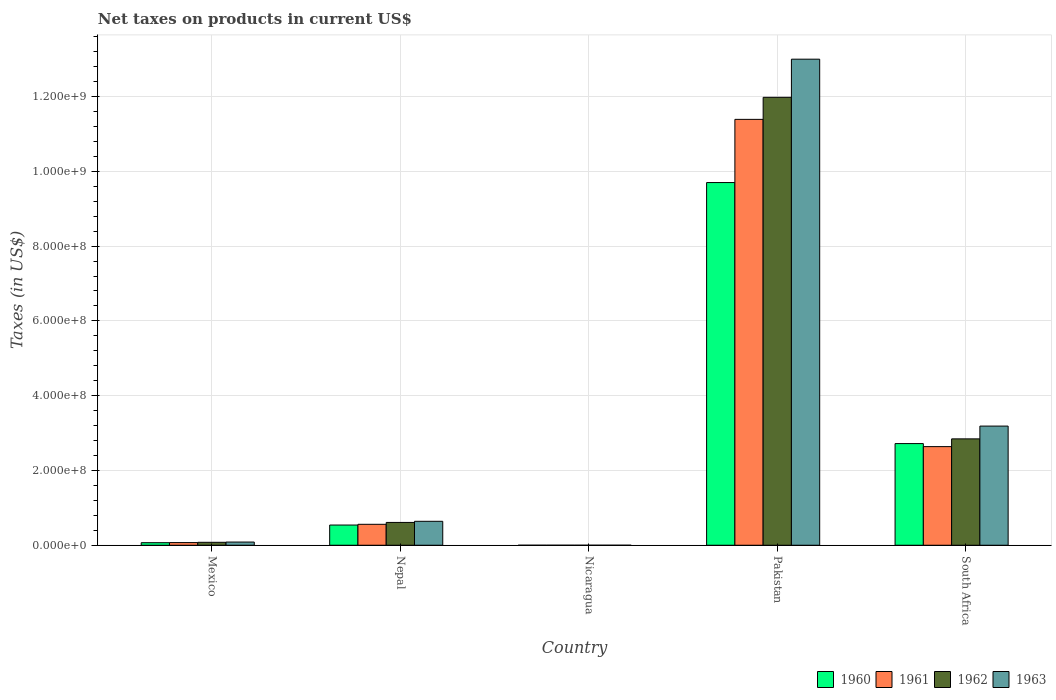How many different coloured bars are there?
Offer a terse response. 4. How many bars are there on the 4th tick from the left?
Provide a short and direct response. 4. What is the label of the 2nd group of bars from the left?
Offer a terse response. Nepal. In how many cases, is the number of bars for a given country not equal to the number of legend labels?
Keep it short and to the point. 0. What is the net taxes on products in 1960 in Mexico?
Give a very brief answer. 6.81e+06. Across all countries, what is the maximum net taxes on products in 1963?
Make the answer very short. 1.30e+09. Across all countries, what is the minimum net taxes on products in 1962?
Ensure brevity in your answer.  0.04. In which country was the net taxes on products in 1963 maximum?
Offer a very short reply. Pakistan. In which country was the net taxes on products in 1962 minimum?
Your answer should be compact. Nicaragua. What is the total net taxes on products in 1963 in the graph?
Provide a succinct answer. 1.69e+09. What is the difference between the net taxes on products in 1963 in Nicaragua and that in South Africa?
Keep it short and to the point. -3.19e+08. What is the difference between the net taxes on products in 1963 in Nepal and the net taxes on products in 1962 in Nicaragua?
Offer a terse response. 6.40e+07. What is the average net taxes on products in 1961 per country?
Offer a very short reply. 2.93e+08. What is the difference between the net taxes on products of/in 1961 and net taxes on products of/in 1963 in Mexico?
Keep it short and to the point. -1.41e+06. In how many countries, is the net taxes on products in 1963 greater than 1040000000 US$?
Offer a terse response. 1. What is the ratio of the net taxes on products in 1962 in Pakistan to that in South Africa?
Keep it short and to the point. 4.21. Is the difference between the net taxes on products in 1961 in Mexico and Nicaragua greater than the difference between the net taxes on products in 1963 in Mexico and Nicaragua?
Offer a very short reply. No. What is the difference between the highest and the second highest net taxes on products in 1962?
Make the answer very short. 9.14e+08. What is the difference between the highest and the lowest net taxes on products in 1960?
Keep it short and to the point. 9.70e+08. In how many countries, is the net taxes on products in 1960 greater than the average net taxes on products in 1960 taken over all countries?
Give a very brief answer. 2. Is it the case that in every country, the sum of the net taxes on products in 1962 and net taxes on products in 1963 is greater than the sum of net taxes on products in 1961 and net taxes on products in 1960?
Offer a terse response. No. What does the 2nd bar from the left in Nicaragua represents?
Make the answer very short. 1961. Is it the case that in every country, the sum of the net taxes on products in 1962 and net taxes on products in 1960 is greater than the net taxes on products in 1961?
Keep it short and to the point. Yes. How many countries are there in the graph?
Give a very brief answer. 5. Does the graph contain any zero values?
Make the answer very short. No. Does the graph contain grids?
Offer a very short reply. Yes. Where does the legend appear in the graph?
Give a very brief answer. Bottom right. How many legend labels are there?
Your response must be concise. 4. How are the legend labels stacked?
Your response must be concise. Horizontal. What is the title of the graph?
Your response must be concise. Net taxes on products in current US$. Does "1997" appear as one of the legend labels in the graph?
Your answer should be compact. No. What is the label or title of the Y-axis?
Provide a short and direct response. Taxes (in US$). What is the Taxes (in US$) of 1960 in Mexico?
Offer a terse response. 6.81e+06. What is the Taxes (in US$) of 1961 in Mexico?
Your answer should be compact. 7.08e+06. What is the Taxes (in US$) of 1962 in Mexico?
Your response must be concise. 7.85e+06. What is the Taxes (in US$) of 1963 in Mexico?
Your answer should be very brief. 8.49e+06. What is the Taxes (in US$) in 1960 in Nepal?
Your answer should be compact. 5.40e+07. What is the Taxes (in US$) of 1961 in Nepal?
Ensure brevity in your answer.  5.60e+07. What is the Taxes (in US$) in 1962 in Nepal?
Provide a succinct answer. 6.10e+07. What is the Taxes (in US$) in 1963 in Nepal?
Provide a succinct answer. 6.40e+07. What is the Taxes (in US$) in 1960 in Nicaragua?
Your answer should be compact. 0.03. What is the Taxes (in US$) of 1961 in Nicaragua?
Your response must be concise. 0.03. What is the Taxes (in US$) in 1962 in Nicaragua?
Keep it short and to the point. 0.04. What is the Taxes (in US$) in 1963 in Nicaragua?
Give a very brief answer. 0.04. What is the Taxes (in US$) of 1960 in Pakistan?
Provide a succinct answer. 9.70e+08. What is the Taxes (in US$) in 1961 in Pakistan?
Provide a succinct answer. 1.14e+09. What is the Taxes (in US$) of 1962 in Pakistan?
Your answer should be compact. 1.20e+09. What is the Taxes (in US$) of 1963 in Pakistan?
Make the answer very short. 1.30e+09. What is the Taxes (in US$) of 1960 in South Africa?
Provide a short and direct response. 2.72e+08. What is the Taxes (in US$) in 1961 in South Africa?
Provide a short and direct response. 2.64e+08. What is the Taxes (in US$) in 1962 in South Africa?
Your answer should be compact. 2.84e+08. What is the Taxes (in US$) in 1963 in South Africa?
Provide a succinct answer. 3.19e+08. Across all countries, what is the maximum Taxes (in US$) of 1960?
Ensure brevity in your answer.  9.70e+08. Across all countries, what is the maximum Taxes (in US$) of 1961?
Offer a terse response. 1.14e+09. Across all countries, what is the maximum Taxes (in US$) in 1962?
Offer a terse response. 1.20e+09. Across all countries, what is the maximum Taxes (in US$) of 1963?
Make the answer very short. 1.30e+09. Across all countries, what is the minimum Taxes (in US$) in 1960?
Offer a terse response. 0.03. Across all countries, what is the minimum Taxes (in US$) in 1961?
Offer a terse response. 0.03. Across all countries, what is the minimum Taxes (in US$) in 1962?
Your answer should be very brief. 0.04. Across all countries, what is the minimum Taxes (in US$) of 1963?
Offer a terse response. 0.04. What is the total Taxes (in US$) of 1960 in the graph?
Offer a terse response. 1.30e+09. What is the total Taxes (in US$) in 1961 in the graph?
Give a very brief answer. 1.47e+09. What is the total Taxes (in US$) of 1962 in the graph?
Offer a very short reply. 1.55e+09. What is the total Taxes (in US$) in 1963 in the graph?
Keep it short and to the point. 1.69e+09. What is the difference between the Taxes (in US$) in 1960 in Mexico and that in Nepal?
Your answer should be very brief. -4.72e+07. What is the difference between the Taxes (in US$) in 1961 in Mexico and that in Nepal?
Give a very brief answer. -4.89e+07. What is the difference between the Taxes (in US$) of 1962 in Mexico and that in Nepal?
Provide a succinct answer. -5.32e+07. What is the difference between the Taxes (in US$) of 1963 in Mexico and that in Nepal?
Make the answer very short. -5.55e+07. What is the difference between the Taxes (in US$) of 1960 in Mexico and that in Nicaragua?
Provide a succinct answer. 6.81e+06. What is the difference between the Taxes (in US$) of 1961 in Mexico and that in Nicaragua?
Give a very brief answer. 7.08e+06. What is the difference between the Taxes (in US$) in 1962 in Mexico and that in Nicaragua?
Keep it short and to the point. 7.85e+06. What is the difference between the Taxes (in US$) of 1963 in Mexico and that in Nicaragua?
Your answer should be compact. 8.49e+06. What is the difference between the Taxes (in US$) in 1960 in Mexico and that in Pakistan?
Provide a short and direct response. -9.63e+08. What is the difference between the Taxes (in US$) of 1961 in Mexico and that in Pakistan?
Your response must be concise. -1.13e+09. What is the difference between the Taxes (in US$) of 1962 in Mexico and that in Pakistan?
Your answer should be compact. -1.19e+09. What is the difference between the Taxes (in US$) in 1963 in Mexico and that in Pakistan?
Ensure brevity in your answer.  -1.29e+09. What is the difference between the Taxes (in US$) in 1960 in Mexico and that in South Africa?
Ensure brevity in your answer.  -2.65e+08. What is the difference between the Taxes (in US$) of 1961 in Mexico and that in South Africa?
Offer a very short reply. -2.57e+08. What is the difference between the Taxes (in US$) of 1962 in Mexico and that in South Africa?
Keep it short and to the point. -2.77e+08. What is the difference between the Taxes (in US$) of 1963 in Mexico and that in South Africa?
Offer a very short reply. -3.10e+08. What is the difference between the Taxes (in US$) of 1960 in Nepal and that in Nicaragua?
Your answer should be very brief. 5.40e+07. What is the difference between the Taxes (in US$) of 1961 in Nepal and that in Nicaragua?
Offer a very short reply. 5.60e+07. What is the difference between the Taxes (in US$) in 1962 in Nepal and that in Nicaragua?
Offer a terse response. 6.10e+07. What is the difference between the Taxes (in US$) of 1963 in Nepal and that in Nicaragua?
Make the answer very short. 6.40e+07. What is the difference between the Taxes (in US$) in 1960 in Nepal and that in Pakistan?
Keep it short and to the point. -9.16e+08. What is the difference between the Taxes (in US$) of 1961 in Nepal and that in Pakistan?
Provide a succinct answer. -1.08e+09. What is the difference between the Taxes (in US$) in 1962 in Nepal and that in Pakistan?
Provide a short and direct response. -1.14e+09. What is the difference between the Taxes (in US$) in 1963 in Nepal and that in Pakistan?
Offer a very short reply. -1.24e+09. What is the difference between the Taxes (in US$) of 1960 in Nepal and that in South Africa?
Ensure brevity in your answer.  -2.18e+08. What is the difference between the Taxes (in US$) in 1961 in Nepal and that in South Africa?
Your response must be concise. -2.08e+08. What is the difference between the Taxes (in US$) of 1962 in Nepal and that in South Africa?
Offer a terse response. -2.23e+08. What is the difference between the Taxes (in US$) in 1963 in Nepal and that in South Africa?
Keep it short and to the point. -2.55e+08. What is the difference between the Taxes (in US$) in 1960 in Nicaragua and that in Pakistan?
Give a very brief answer. -9.70e+08. What is the difference between the Taxes (in US$) of 1961 in Nicaragua and that in Pakistan?
Ensure brevity in your answer.  -1.14e+09. What is the difference between the Taxes (in US$) in 1962 in Nicaragua and that in Pakistan?
Ensure brevity in your answer.  -1.20e+09. What is the difference between the Taxes (in US$) in 1963 in Nicaragua and that in Pakistan?
Provide a short and direct response. -1.30e+09. What is the difference between the Taxes (in US$) of 1960 in Nicaragua and that in South Africa?
Make the answer very short. -2.72e+08. What is the difference between the Taxes (in US$) of 1961 in Nicaragua and that in South Africa?
Keep it short and to the point. -2.64e+08. What is the difference between the Taxes (in US$) of 1962 in Nicaragua and that in South Africa?
Your answer should be compact. -2.84e+08. What is the difference between the Taxes (in US$) in 1963 in Nicaragua and that in South Africa?
Provide a succinct answer. -3.19e+08. What is the difference between the Taxes (in US$) in 1960 in Pakistan and that in South Africa?
Offer a very short reply. 6.98e+08. What is the difference between the Taxes (in US$) in 1961 in Pakistan and that in South Africa?
Make the answer very short. 8.75e+08. What is the difference between the Taxes (in US$) in 1962 in Pakistan and that in South Africa?
Provide a succinct answer. 9.14e+08. What is the difference between the Taxes (in US$) of 1963 in Pakistan and that in South Africa?
Offer a terse response. 9.81e+08. What is the difference between the Taxes (in US$) in 1960 in Mexico and the Taxes (in US$) in 1961 in Nepal?
Provide a succinct answer. -4.92e+07. What is the difference between the Taxes (in US$) in 1960 in Mexico and the Taxes (in US$) in 1962 in Nepal?
Your answer should be very brief. -5.42e+07. What is the difference between the Taxes (in US$) of 1960 in Mexico and the Taxes (in US$) of 1963 in Nepal?
Your answer should be very brief. -5.72e+07. What is the difference between the Taxes (in US$) of 1961 in Mexico and the Taxes (in US$) of 1962 in Nepal?
Provide a short and direct response. -5.39e+07. What is the difference between the Taxes (in US$) in 1961 in Mexico and the Taxes (in US$) in 1963 in Nepal?
Your answer should be compact. -5.69e+07. What is the difference between the Taxes (in US$) in 1962 in Mexico and the Taxes (in US$) in 1963 in Nepal?
Provide a short and direct response. -5.62e+07. What is the difference between the Taxes (in US$) of 1960 in Mexico and the Taxes (in US$) of 1961 in Nicaragua?
Ensure brevity in your answer.  6.81e+06. What is the difference between the Taxes (in US$) in 1960 in Mexico and the Taxes (in US$) in 1962 in Nicaragua?
Provide a succinct answer. 6.81e+06. What is the difference between the Taxes (in US$) of 1960 in Mexico and the Taxes (in US$) of 1963 in Nicaragua?
Keep it short and to the point. 6.81e+06. What is the difference between the Taxes (in US$) of 1961 in Mexico and the Taxes (in US$) of 1962 in Nicaragua?
Your answer should be very brief. 7.08e+06. What is the difference between the Taxes (in US$) in 1961 in Mexico and the Taxes (in US$) in 1963 in Nicaragua?
Ensure brevity in your answer.  7.08e+06. What is the difference between the Taxes (in US$) in 1962 in Mexico and the Taxes (in US$) in 1963 in Nicaragua?
Your answer should be very brief. 7.85e+06. What is the difference between the Taxes (in US$) of 1960 in Mexico and the Taxes (in US$) of 1961 in Pakistan?
Offer a terse response. -1.13e+09. What is the difference between the Taxes (in US$) of 1960 in Mexico and the Taxes (in US$) of 1962 in Pakistan?
Ensure brevity in your answer.  -1.19e+09. What is the difference between the Taxes (in US$) in 1960 in Mexico and the Taxes (in US$) in 1963 in Pakistan?
Your answer should be compact. -1.29e+09. What is the difference between the Taxes (in US$) of 1961 in Mexico and the Taxes (in US$) of 1962 in Pakistan?
Offer a terse response. -1.19e+09. What is the difference between the Taxes (in US$) of 1961 in Mexico and the Taxes (in US$) of 1963 in Pakistan?
Your answer should be compact. -1.29e+09. What is the difference between the Taxes (in US$) of 1962 in Mexico and the Taxes (in US$) of 1963 in Pakistan?
Provide a short and direct response. -1.29e+09. What is the difference between the Taxes (in US$) of 1960 in Mexico and the Taxes (in US$) of 1961 in South Africa?
Provide a short and direct response. -2.57e+08. What is the difference between the Taxes (in US$) of 1960 in Mexico and the Taxes (in US$) of 1962 in South Africa?
Offer a very short reply. -2.78e+08. What is the difference between the Taxes (in US$) in 1960 in Mexico and the Taxes (in US$) in 1963 in South Africa?
Make the answer very short. -3.12e+08. What is the difference between the Taxes (in US$) in 1961 in Mexico and the Taxes (in US$) in 1962 in South Africa?
Ensure brevity in your answer.  -2.77e+08. What is the difference between the Taxes (in US$) in 1961 in Mexico and the Taxes (in US$) in 1963 in South Africa?
Your answer should be very brief. -3.12e+08. What is the difference between the Taxes (in US$) of 1962 in Mexico and the Taxes (in US$) of 1963 in South Africa?
Your response must be concise. -3.11e+08. What is the difference between the Taxes (in US$) of 1960 in Nepal and the Taxes (in US$) of 1961 in Nicaragua?
Give a very brief answer. 5.40e+07. What is the difference between the Taxes (in US$) of 1960 in Nepal and the Taxes (in US$) of 1962 in Nicaragua?
Provide a succinct answer. 5.40e+07. What is the difference between the Taxes (in US$) in 1960 in Nepal and the Taxes (in US$) in 1963 in Nicaragua?
Ensure brevity in your answer.  5.40e+07. What is the difference between the Taxes (in US$) of 1961 in Nepal and the Taxes (in US$) of 1962 in Nicaragua?
Keep it short and to the point. 5.60e+07. What is the difference between the Taxes (in US$) of 1961 in Nepal and the Taxes (in US$) of 1963 in Nicaragua?
Ensure brevity in your answer.  5.60e+07. What is the difference between the Taxes (in US$) of 1962 in Nepal and the Taxes (in US$) of 1963 in Nicaragua?
Provide a succinct answer. 6.10e+07. What is the difference between the Taxes (in US$) in 1960 in Nepal and the Taxes (in US$) in 1961 in Pakistan?
Your answer should be very brief. -1.08e+09. What is the difference between the Taxes (in US$) in 1960 in Nepal and the Taxes (in US$) in 1962 in Pakistan?
Your answer should be very brief. -1.14e+09. What is the difference between the Taxes (in US$) of 1960 in Nepal and the Taxes (in US$) of 1963 in Pakistan?
Your response must be concise. -1.25e+09. What is the difference between the Taxes (in US$) in 1961 in Nepal and the Taxes (in US$) in 1962 in Pakistan?
Make the answer very short. -1.14e+09. What is the difference between the Taxes (in US$) in 1961 in Nepal and the Taxes (in US$) in 1963 in Pakistan?
Offer a very short reply. -1.24e+09. What is the difference between the Taxes (in US$) in 1962 in Nepal and the Taxes (in US$) in 1963 in Pakistan?
Your answer should be compact. -1.24e+09. What is the difference between the Taxes (in US$) in 1960 in Nepal and the Taxes (in US$) in 1961 in South Africa?
Provide a short and direct response. -2.10e+08. What is the difference between the Taxes (in US$) in 1960 in Nepal and the Taxes (in US$) in 1962 in South Africa?
Your response must be concise. -2.30e+08. What is the difference between the Taxes (in US$) of 1960 in Nepal and the Taxes (in US$) of 1963 in South Africa?
Keep it short and to the point. -2.65e+08. What is the difference between the Taxes (in US$) of 1961 in Nepal and the Taxes (in US$) of 1962 in South Africa?
Provide a succinct answer. -2.28e+08. What is the difference between the Taxes (in US$) in 1961 in Nepal and the Taxes (in US$) in 1963 in South Africa?
Provide a succinct answer. -2.63e+08. What is the difference between the Taxes (in US$) in 1962 in Nepal and the Taxes (in US$) in 1963 in South Africa?
Offer a terse response. -2.58e+08. What is the difference between the Taxes (in US$) of 1960 in Nicaragua and the Taxes (in US$) of 1961 in Pakistan?
Offer a very short reply. -1.14e+09. What is the difference between the Taxes (in US$) of 1960 in Nicaragua and the Taxes (in US$) of 1962 in Pakistan?
Keep it short and to the point. -1.20e+09. What is the difference between the Taxes (in US$) in 1960 in Nicaragua and the Taxes (in US$) in 1963 in Pakistan?
Offer a very short reply. -1.30e+09. What is the difference between the Taxes (in US$) in 1961 in Nicaragua and the Taxes (in US$) in 1962 in Pakistan?
Keep it short and to the point. -1.20e+09. What is the difference between the Taxes (in US$) in 1961 in Nicaragua and the Taxes (in US$) in 1963 in Pakistan?
Provide a short and direct response. -1.30e+09. What is the difference between the Taxes (in US$) of 1962 in Nicaragua and the Taxes (in US$) of 1963 in Pakistan?
Your answer should be very brief. -1.30e+09. What is the difference between the Taxes (in US$) in 1960 in Nicaragua and the Taxes (in US$) in 1961 in South Africa?
Your response must be concise. -2.64e+08. What is the difference between the Taxes (in US$) in 1960 in Nicaragua and the Taxes (in US$) in 1962 in South Africa?
Your response must be concise. -2.84e+08. What is the difference between the Taxes (in US$) of 1960 in Nicaragua and the Taxes (in US$) of 1963 in South Africa?
Keep it short and to the point. -3.19e+08. What is the difference between the Taxes (in US$) in 1961 in Nicaragua and the Taxes (in US$) in 1962 in South Africa?
Offer a very short reply. -2.84e+08. What is the difference between the Taxes (in US$) in 1961 in Nicaragua and the Taxes (in US$) in 1963 in South Africa?
Make the answer very short. -3.19e+08. What is the difference between the Taxes (in US$) in 1962 in Nicaragua and the Taxes (in US$) in 1963 in South Africa?
Provide a succinct answer. -3.19e+08. What is the difference between the Taxes (in US$) of 1960 in Pakistan and the Taxes (in US$) of 1961 in South Africa?
Provide a short and direct response. 7.06e+08. What is the difference between the Taxes (in US$) of 1960 in Pakistan and the Taxes (in US$) of 1962 in South Africa?
Keep it short and to the point. 6.86e+08. What is the difference between the Taxes (in US$) in 1960 in Pakistan and the Taxes (in US$) in 1963 in South Africa?
Your response must be concise. 6.51e+08. What is the difference between the Taxes (in US$) of 1961 in Pakistan and the Taxes (in US$) of 1962 in South Africa?
Provide a succinct answer. 8.55e+08. What is the difference between the Taxes (in US$) of 1961 in Pakistan and the Taxes (in US$) of 1963 in South Africa?
Provide a succinct answer. 8.20e+08. What is the difference between the Taxes (in US$) in 1962 in Pakistan and the Taxes (in US$) in 1963 in South Africa?
Give a very brief answer. 8.79e+08. What is the average Taxes (in US$) of 1960 per country?
Give a very brief answer. 2.61e+08. What is the average Taxes (in US$) in 1961 per country?
Provide a short and direct response. 2.93e+08. What is the average Taxes (in US$) of 1962 per country?
Provide a succinct answer. 3.10e+08. What is the average Taxes (in US$) of 1963 per country?
Offer a terse response. 3.38e+08. What is the difference between the Taxes (in US$) of 1960 and Taxes (in US$) of 1961 in Mexico?
Make the answer very short. -2.73e+05. What is the difference between the Taxes (in US$) in 1960 and Taxes (in US$) in 1962 in Mexico?
Your response must be concise. -1.04e+06. What is the difference between the Taxes (in US$) in 1960 and Taxes (in US$) in 1963 in Mexico?
Your answer should be very brief. -1.69e+06. What is the difference between the Taxes (in US$) in 1961 and Taxes (in US$) in 1962 in Mexico?
Keep it short and to the point. -7.69e+05. What is the difference between the Taxes (in US$) in 1961 and Taxes (in US$) in 1963 in Mexico?
Offer a terse response. -1.41e+06. What is the difference between the Taxes (in US$) of 1962 and Taxes (in US$) of 1963 in Mexico?
Provide a succinct answer. -6.43e+05. What is the difference between the Taxes (in US$) in 1960 and Taxes (in US$) in 1962 in Nepal?
Offer a terse response. -7.00e+06. What is the difference between the Taxes (in US$) in 1960 and Taxes (in US$) in 1963 in Nepal?
Provide a succinct answer. -1.00e+07. What is the difference between the Taxes (in US$) in 1961 and Taxes (in US$) in 1962 in Nepal?
Provide a short and direct response. -5.00e+06. What is the difference between the Taxes (in US$) in 1961 and Taxes (in US$) in 1963 in Nepal?
Make the answer very short. -8.00e+06. What is the difference between the Taxes (in US$) in 1960 and Taxes (in US$) in 1961 in Nicaragua?
Make the answer very short. -0. What is the difference between the Taxes (in US$) of 1960 and Taxes (in US$) of 1962 in Nicaragua?
Make the answer very short. -0.01. What is the difference between the Taxes (in US$) of 1960 and Taxes (in US$) of 1963 in Nicaragua?
Your answer should be very brief. -0.01. What is the difference between the Taxes (in US$) in 1961 and Taxes (in US$) in 1962 in Nicaragua?
Offer a very short reply. -0. What is the difference between the Taxes (in US$) of 1961 and Taxes (in US$) of 1963 in Nicaragua?
Provide a short and direct response. -0.01. What is the difference between the Taxes (in US$) in 1962 and Taxes (in US$) in 1963 in Nicaragua?
Provide a short and direct response. -0.01. What is the difference between the Taxes (in US$) in 1960 and Taxes (in US$) in 1961 in Pakistan?
Your answer should be very brief. -1.69e+08. What is the difference between the Taxes (in US$) in 1960 and Taxes (in US$) in 1962 in Pakistan?
Provide a succinct answer. -2.28e+08. What is the difference between the Taxes (in US$) of 1960 and Taxes (in US$) of 1963 in Pakistan?
Keep it short and to the point. -3.30e+08. What is the difference between the Taxes (in US$) in 1961 and Taxes (in US$) in 1962 in Pakistan?
Your answer should be compact. -5.90e+07. What is the difference between the Taxes (in US$) in 1961 and Taxes (in US$) in 1963 in Pakistan?
Provide a short and direct response. -1.61e+08. What is the difference between the Taxes (in US$) of 1962 and Taxes (in US$) of 1963 in Pakistan?
Offer a very short reply. -1.02e+08. What is the difference between the Taxes (in US$) in 1960 and Taxes (in US$) in 1961 in South Africa?
Offer a very short reply. 8.10e+06. What is the difference between the Taxes (in US$) in 1960 and Taxes (in US$) in 1962 in South Africa?
Your answer should be compact. -1.26e+07. What is the difference between the Taxes (in US$) of 1960 and Taxes (in US$) of 1963 in South Africa?
Offer a very short reply. -4.68e+07. What is the difference between the Taxes (in US$) of 1961 and Taxes (in US$) of 1962 in South Africa?
Offer a very short reply. -2.07e+07. What is the difference between the Taxes (in US$) of 1961 and Taxes (in US$) of 1963 in South Africa?
Provide a succinct answer. -5.49e+07. What is the difference between the Taxes (in US$) in 1962 and Taxes (in US$) in 1963 in South Africa?
Your response must be concise. -3.42e+07. What is the ratio of the Taxes (in US$) in 1960 in Mexico to that in Nepal?
Keep it short and to the point. 0.13. What is the ratio of the Taxes (in US$) in 1961 in Mexico to that in Nepal?
Your answer should be very brief. 0.13. What is the ratio of the Taxes (in US$) of 1962 in Mexico to that in Nepal?
Provide a short and direct response. 0.13. What is the ratio of the Taxes (in US$) of 1963 in Mexico to that in Nepal?
Offer a terse response. 0.13. What is the ratio of the Taxes (in US$) of 1960 in Mexico to that in Nicaragua?
Ensure brevity in your answer.  2.29e+08. What is the ratio of the Taxes (in US$) in 1961 in Mexico to that in Nicaragua?
Your answer should be compact. 2.27e+08. What is the ratio of the Taxes (in US$) of 1962 in Mexico to that in Nicaragua?
Make the answer very short. 2.22e+08. What is the ratio of the Taxes (in US$) in 1963 in Mexico to that in Nicaragua?
Make the answer very short. 2.04e+08. What is the ratio of the Taxes (in US$) in 1960 in Mexico to that in Pakistan?
Give a very brief answer. 0.01. What is the ratio of the Taxes (in US$) of 1961 in Mexico to that in Pakistan?
Provide a succinct answer. 0.01. What is the ratio of the Taxes (in US$) in 1962 in Mexico to that in Pakistan?
Provide a succinct answer. 0.01. What is the ratio of the Taxes (in US$) of 1963 in Mexico to that in Pakistan?
Ensure brevity in your answer.  0.01. What is the ratio of the Taxes (in US$) of 1960 in Mexico to that in South Africa?
Your response must be concise. 0.03. What is the ratio of the Taxes (in US$) in 1961 in Mexico to that in South Africa?
Make the answer very short. 0.03. What is the ratio of the Taxes (in US$) in 1962 in Mexico to that in South Africa?
Your response must be concise. 0.03. What is the ratio of the Taxes (in US$) of 1963 in Mexico to that in South Africa?
Your answer should be compact. 0.03. What is the ratio of the Taxes (in US$) of 1960 in Nepal to that in Nicaragua?
Ensure brevity in your answer.  1.81e+09. What is the ratio of the Taxes (in US$) in 1961 in Nepal to that in Nicaragua?
Provide a succinct answer. 1.80e+09. What is the ratio of the Taxes (in US$) in 1962 in Nepal to that in Nicaragua?
Ensure brevity in your answer.  1.73e+09. What is the ratio of the Taxes (in US$) in 1963 in Nepal to that in Nicaragua?
Offer a terse response. 1.54e+09. What is the ratio of the Taxes (in US$) of 1960 in Nepal to that in Pakistan?
Give a very brief answer. 0.06. What is the ratio of the Taxes (in US$) in 1961 in Nepal to that in Pakistan?
Offer a terse response. 0.05. What is the ratio of the Taxes (in US$) of 1962 in Nepal to that in Pakistan?
Ensure brevity in your answer.  0.05. What is the ratio of the Taxes (in US$) in 1963 in Nepal to that in Pakistan?
Ensure brevity in your answer.  0.05. What is the ratio of the Taxes (in US$) in 1960 in Nepal to that in South Africa?
Give a very brief answer. 0.2. What is the ratio of the Taxes (in US$) in 1961 in Nepal to that in South Africa?
Your answer should be very brief. 0.21. What is the ratio of the Taxes (in US$) of 1962 in Nepal to that in South Africa?
Make the answer very short. 0.21. What is the ratio of the Taxes (in US$) in 1963 in Nepal to that in South Africa?
Your answer should be very brief. 0.2. What is the ratio of the Taxes (in US$) of 1960 in Nicaragua to that in Pakistan?
Provide a succinct answer. 0. What is the ratio of the Taxes (in US$) of 1961 in Nicaragua to that in South Africa?
Keep it short and to the point. 0. What is the ratio of the Taxes (in US$) of 1963 in Nicaragua to that in South Africa?
Your answer should be very brief. 0. What is the ratio of the Taxes (in US$) in 1960 in Pakistan to that in South Africa?
Your answer should be compact. 3.57. What is the ratio of the Taxes (in US$) in 1961 in Pakistan to that in South Africa?
Your answer should be very brief. 4.32. What is the ratio of the Taxes (in US$) in 1962 in Pakistan to that in South Africa?
Provide a succinct answer. 4.21. What is the ratio of the Taxes (in US$) in 1963 in Pakistan to that in South Africa?
Make the answer very short. 4.08. What is the difference between the highest and the second highest Taxes (in US$) in 1960?
Give a very brief answer. 6.98e+08. What is the difference between the highest and the second highest Taxes (in US$) in 1961?
Your response must be concise. 8.75e+08. What is the difference between the highest and the second highest Taxes (in US$) in 1962?
Make the answer very short. 9.14e+08. What is the difference between the highest and the second highest Taxes (in US$) of 1963?
Your answer should be compact. 9.81e+08. What is the difference between the highest and the lowest Taxes (in US$) in 1960?
Your response must be concise. 9.70e+08. What is the difference between the highest and the lowest Taxes (in US$) of 1961?
Offer a terse response. 1.14e+09. What is the difference between the highest and the lowest Taxes (in US$) of 1962?
Provide a succinct answer. 1.20e+09. What is the difference between the highest and the lowest Taxes (in US$) of 1963?
Your response must be concise. 1.30e+09. 